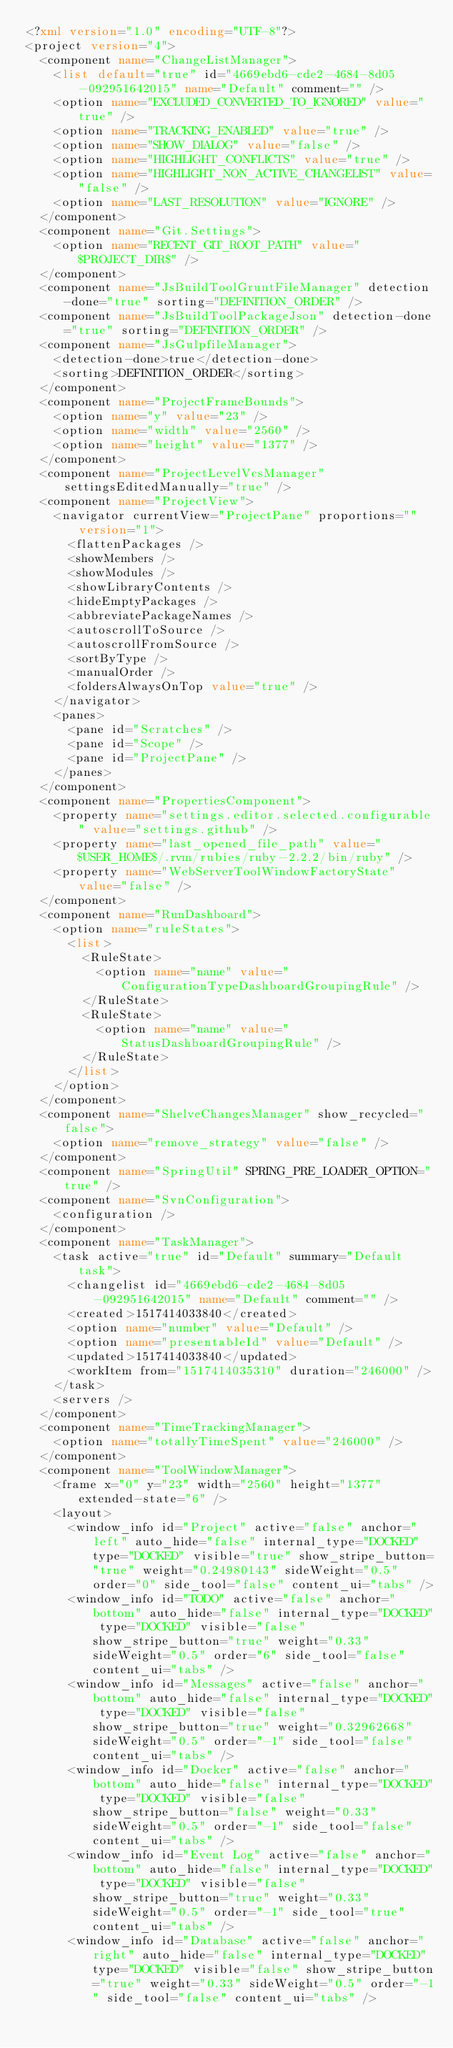Convert code to text. <code><loc_0><loc_0><loc_500><loc_500><_XML_><?xml version="1.0" encoding="UTF-8"?>
<project version="4">
  <component name="ChangeListManager">
    <list default="true" id="4669ebd6-cde2-4684-8d05-092951642015" name="Default" comment="" />
    <option name="EXCLUDED_CONVERTED_TO_IGNORED" value="true" />
    <option name="TRACKING_ENABLED" value="true" />
    <option name="SHOW_DIALOG" value="false" />
    <option name="HIGHLIGHT_CONFLICTS" value="true" />
    <option name="HIGHLIGHT_NON_ACTIVE_CHANGELIST" value="false" />
    <option name="LAST_RESOLUTION" value="IGNORE" />
  </component>
  <component name="Git.Settings">
    <option name="RECENT_GIT_ROOT_PATH" value="$PROJECT_DIR$" />
  </component>
  <component name="JsBuildToolGruntFileManager" detection-done="true" sorting="DEFINITION_ORDER" />
  <component name="JsBuildToolPackageJson" detection-done="true" sorting="DEFINITION_ORDER" />
  <component name="JsGulpfileManager">
    <detection-done>true</detection-done>
    <sorting>DEFINITION_ORDER</sorting>
  </component>
  <component name="ProjectFrameBounds">
    <option name="y" value="23" />
    <option name="width" value="2560" />
    <option name="height" value="1377" />
  </component>
  <component name="ProjectLevelVcsManager" settingsEditedManually="true" />
  <component name="ProjectView">
    <navigator currentView="ProjectPane" proportions="" version="1">
      <flattenPackages />
      <showMembers />
      <showModules />
      <showLibraryContents />
      <hideEmptyPackages />
      <abbreviatePackageNames />
      <autoscrollToSource />
      <autoscrollFromSource />
      <sortByType />
      <manualOrder />
      <foldersAlwaysOnTop value="true" />
    </navigator>
    <panes>
      <pane id="Scratches" />
      <pane id="Scope" />
      <pane id="ProjectPane" />
    </panes>
  </component>
  <component name="PropertiesComponent">
    <property name="settings.editor.selected.configurable" value="settings.github" />
    <property name="last_opened_file_path" value="$USER_HOME$/.rvm/rubies/ruby-2.2.2/bin/ruby" />
    <property name="WebServerToolWindowFactoryState" value="false" />
  </component>
  <component name="RunDashboard">
    <option name="ruleStates">
      <list>
        <RuleState>
          <option name="name" value="ConfigurationTypeDashboardGroupingRule" />
        </RuleState>
        <RuleState>
          <option name="name" value="StatusDashboardGroupingRule" />
        </RuleState>
      </list>
    </option>
  </component>
  <component name="ShelveChangesManager" show_recycled="false">
    <option name="remove_strategy" value="false" />
  </component>
  <component name="SpringUtil" SPRING_PRE_LOADER_OPTION="true" />
  <component name="SvnConfiguration">
    <configuration />
  </component>
  <component name="TaskManager">
    <task active="true" id="Default" summary="Default task">
      <changelist id="4669ebd6-cde2-4684-8d05-092951642015" name="Default" comment="" />
      <created>1517414033840</created>
      <option name="number" value="Default" />
      <option name="presentableId" value="Default" />
      <updated>1517414033840</updated>
      <workItem from="1517414035310" duration="246000" />
    </task>
    <servers />
  </component>
  <component name="TimeTrackingManager">
    <option name="totallyTimeSpent" value="246000" />
  </component>
  <component name="ToolWindowManager">
    <frame x="0" y="23" width="2560" height="1377" extended-state="6" />
    <layout>
      <window_info id="Project" active="false" anchor="left" auto_hide="false" internal_type="DOCKED" type="DOCKED" visible="true" show_stripe_button="true" weight="0.24980143" sideWeight="0.5" order="0" side_tool="false" content_ui="tabs" />
      <window_info id="TODO" active="false" anchor="bottom" auto_hide="false" internal_type="DOCKED" type="DOCKED" visible="false" show_stripe_button="true" weight="0.33" sideWeight="0.5" order="6" side_tool="false" content_ui="tabs" />
      <window_info id="Messages" active="false" anchor="bottom" auto_hide="false" internal_type="DOCKED" type="DOCKED" visible="false" show_stripe_button="true" weight="0.32962668" sideWeight="0.5" order="-1" side_tool="false" content_ui="tabs" />
      <window_info id="Docker" active="false" anchor="bottom" auto_hide="false" internal_type="DOCKED" type="DOCKED" visible="false" show_stripe_button="false" weight="0.33" sideWeight="0.5" order="-1" side_tool="false" content_ui="tabs" />
      <window_info id="Event Log" active="false" anchor="bottom" auto_hide="false" internal_type="DOCKED" type="DOCKED" visible="false" show_stripe_button="true" weight="0.33" sideWeight="0.5" order="-1" side_tool="true" content_ui="tabs" />
      <window_info id="Database" active="false" anchor="right" auto_hide="false" internal_type="DOCKED" type="DOCKED" visible="false" show_stripe_button="true" weight="0.33" sideWeight="0.5" order="-1" side_tool="false" content_ui="tabs" /></code> 